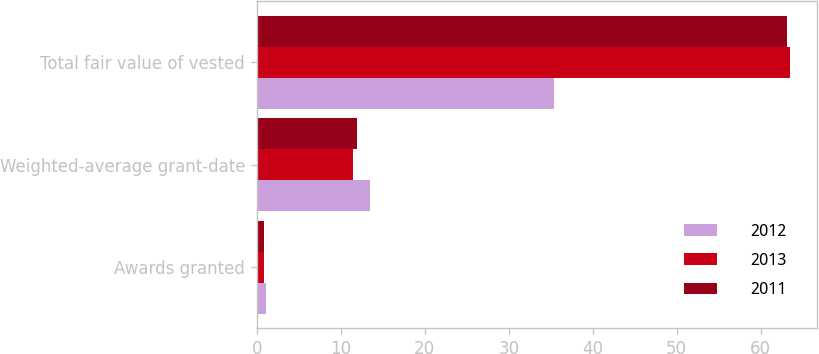<chart> <loc_0><loc_0><loc_500><loc_500><stacked_bar_chart><ecel><fcel>Awards granted<fcel>Weighted-average grant-date<fcel>Total fair value of vested<nl><fcel>2012<fcel>1.1<fcel>13.51<fcel>35.4<nl><fcel>2013<fcel>0.9<fcel>11.43<fcel>63.5<nl><fcel>2011<fcel>0.8<fcel>11.94<fcel>63.1<nl></chart> 